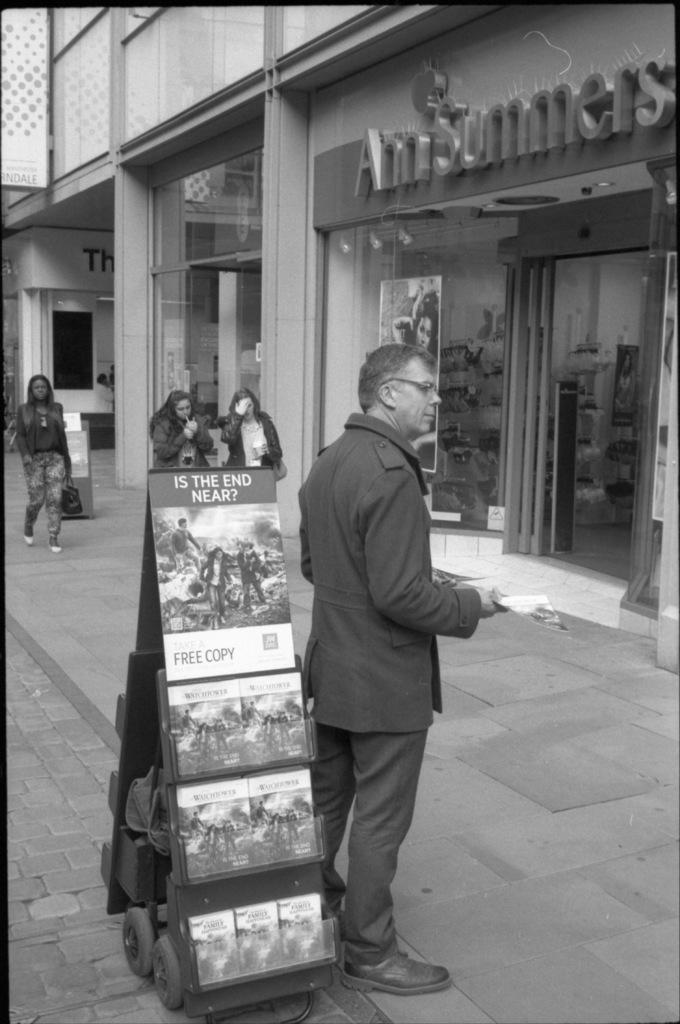Describe this image in one or two sentences. This is a black and white image. In this image we can see a stand with wheels. On that there are some items. Near to that there is a person wearing specs and he is standing. And he is holding something in the hand. There is a sidewalk. There are few people. There is a building. On that there is a name. 